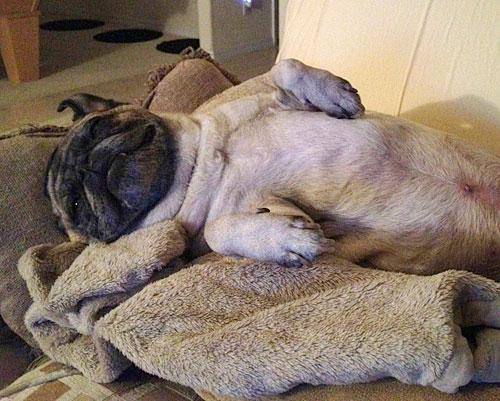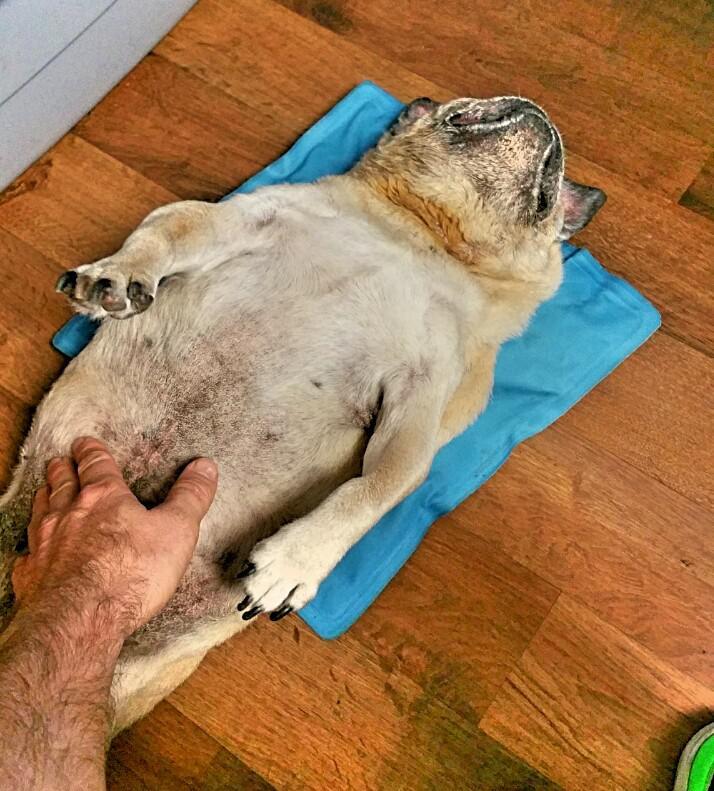The first image is the image on the left, the second image is the image on the right. Given the left and right images, does the statement "There is at least one pug wearing a collar with red in it." hold true? Answer yes or no. No. The first image is the image on the left, the second image is the image on the right. For the images shown, is this caption "A pug with a dark muzzle is sleeping on a blanket and in contact with something beige and plush in the left image." true? Answer yes or no. Yes. 